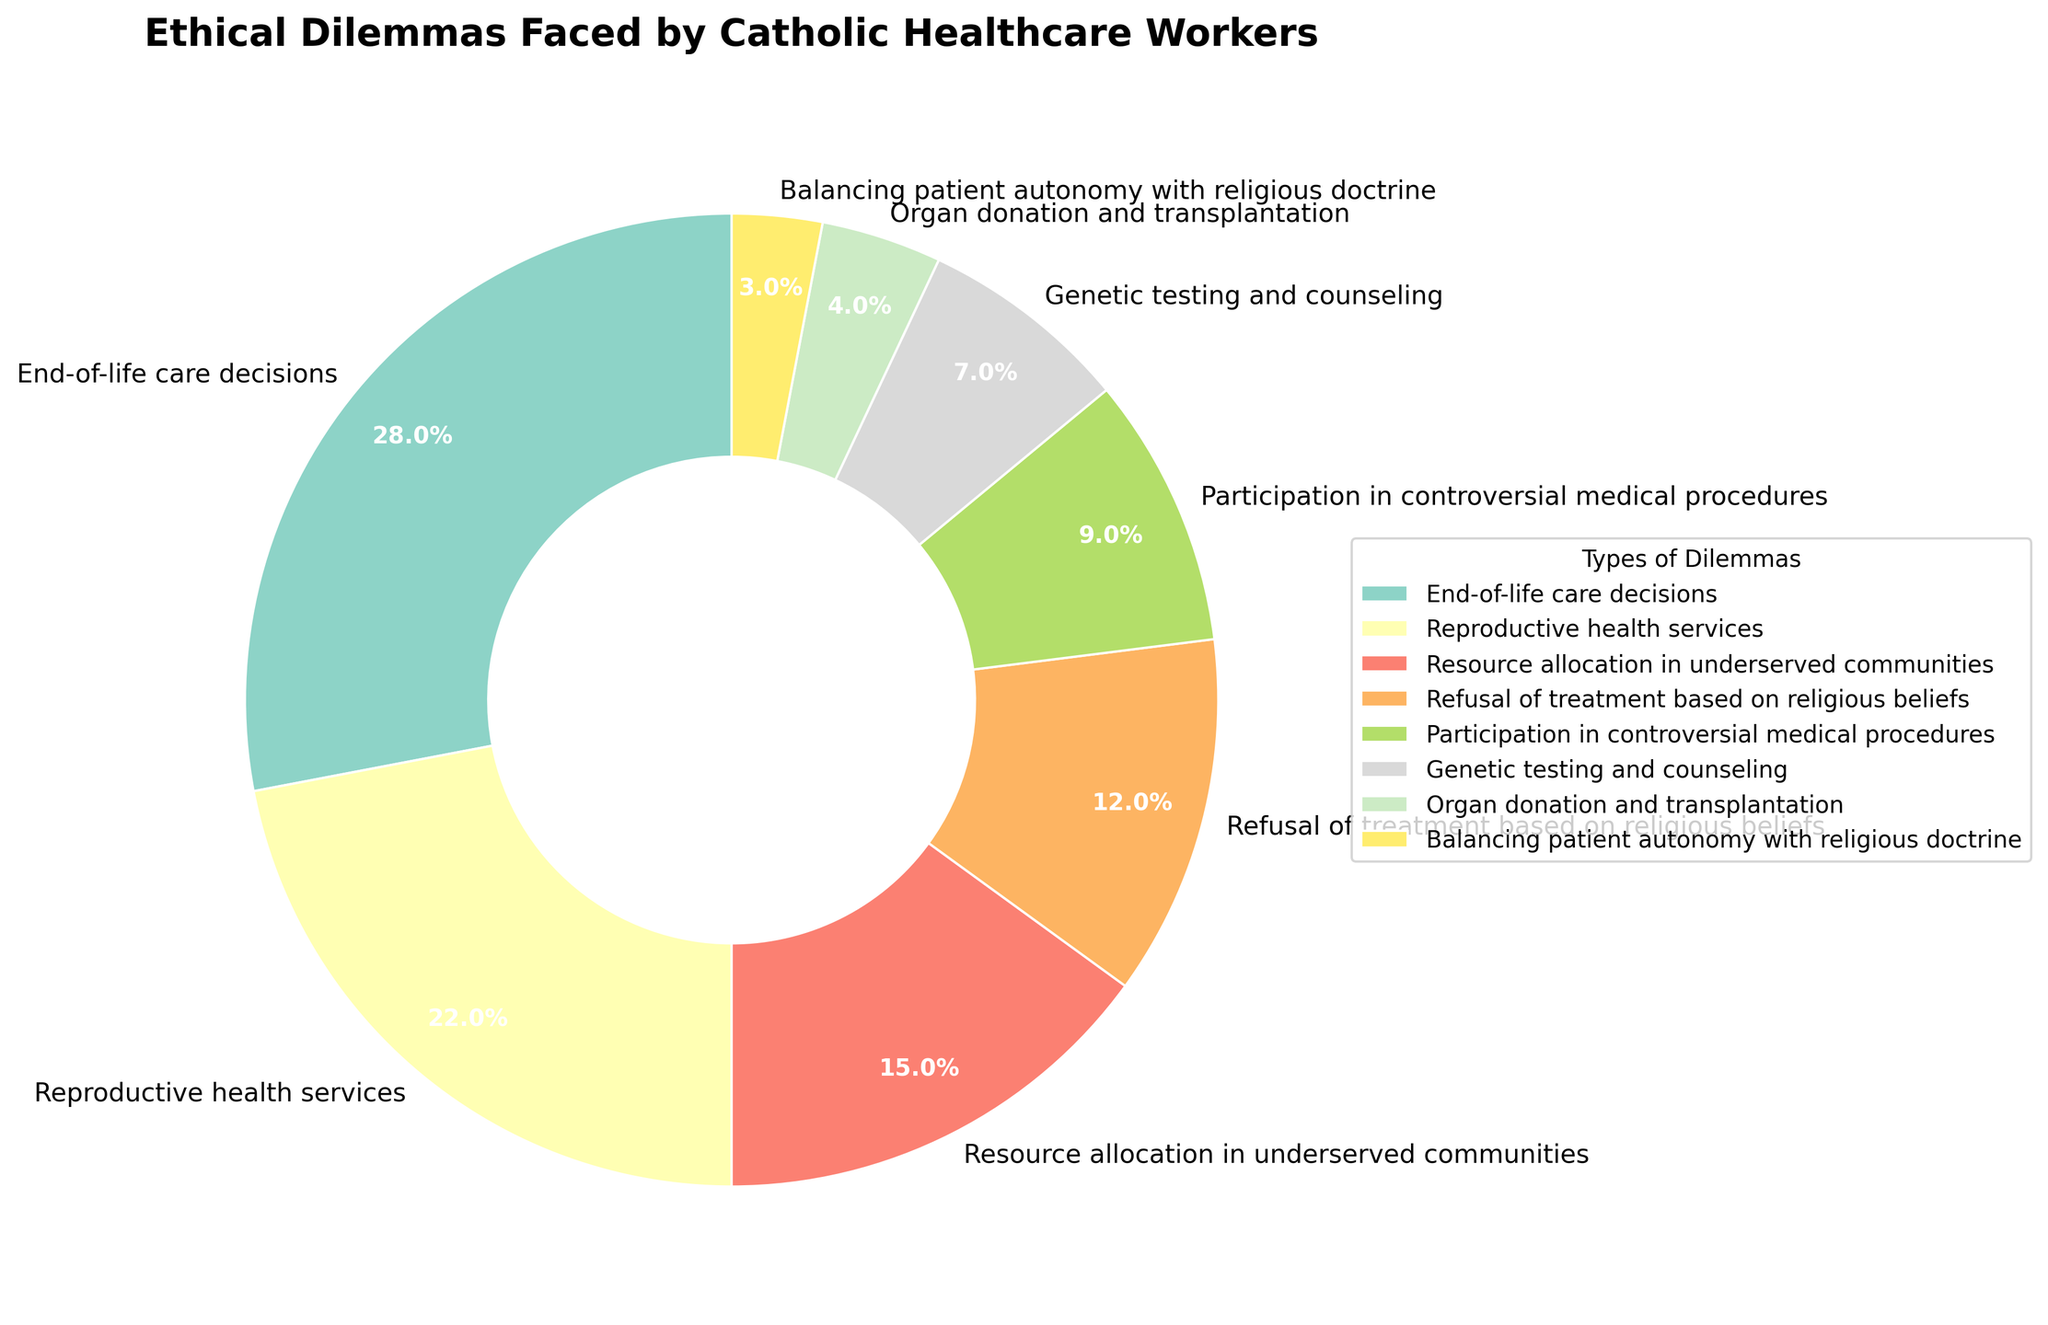Which type of ethical dilemma is faced by Catholic healthcare workers the most? The pie chart shows the different types of ethical dilemmas and their respective percentages. The largest segment corresponds to “End-of-life care decisions” at 28%.
Answer: End-of-life care decisions How much more common are end-of-life care decisions compared to genetic testing and counseling? End-of-life care decisions account for 28%, while genetic testing and counseling account for 7%. The difference is 28% - 7% = 21%.
Answer: 21% Which two types of ethical dilemmas together make up more than half of the total percentage? End-of-life care decisions (28%) and reproductive health services (22%) add up to 28% + 22% = 50%. These two categories together make up exactly half of the total.
Answer: End-of-life care decisions and reproductive health services Is the percentage for resource allocation in underserved communities greater than the percentage for participation in controversial medical procedures? The pie chart shows resource allocation in underserved communities at 15% and participation in controversial medical procedures at 9%. Since 15% is greater than 9%, resource allocation has a higher percentage.
Answer: Yes What is the combined percentage for dilemmas related to refusal of treatment based on religious beliefs and organ donation and transplantation? Refusal of treatment based on religious beliefs is 12%, and organ donation and transplantation is 4%. Their combined percentage is 12% + 4% = 16%.
Answer: 16% Which type of ethical dilemma has the smallest representation in the pie chart? The smallest segment in the pie chart represents “Balancing patient autonomy with religious doctrine” at 3%.
Answer: Balancing patient autonomy with religious doctrine How do the percentages of reproductive health services and refusal of treatment based on religious beliefs compare? Reproductive health services account for 22%, while refusal of treatment based on religious beliefs accounts for 12%. Comparing the two, 22% is greater than 12%.
Answer: Reproductive health services is higher What percentage of ethical dilemmas are related to controversial medical procedures and genetic testing combined? Participation in controversial medical procedures is 9%, and genetic testing and counseling is 7%. Summing them up, 9% + 7% = 16%.
Answer: 16% What is the difference in percentage between resource allocation in underserved communities and organ donation and transplantation? Resource allocation in underserved communities is 15%, and organ donation and transplantation is 4%. The difference is 15% - 4% = 11%.
Answer: 11% 